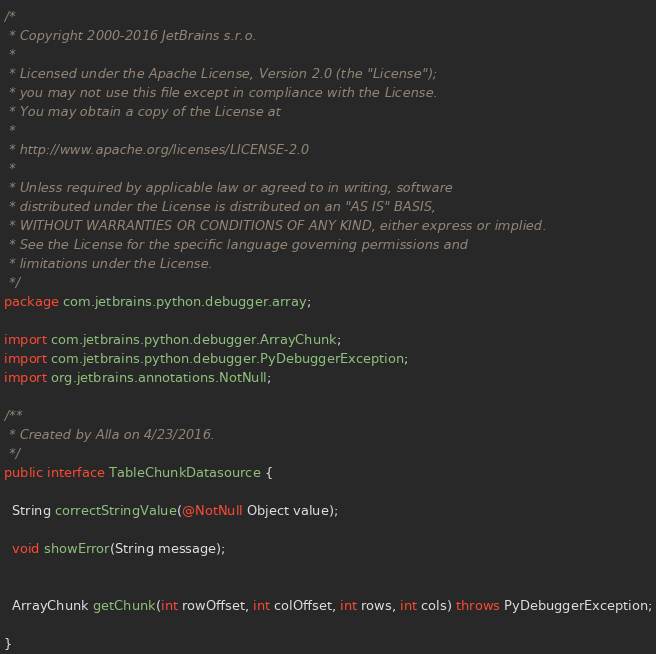Convert code to text. <code><loc_0><loc_0><loc_500><loc_500><_Java_>/*
 * Copyright 2000-2016 JetBrains s.r.o.
 *
 * Licensed under the Apache License, Version 2.0 (the "License");
 * you may not use this file except in compliance with the License.
 * You may obtain a copy of the License at
 *
 * http://www.apache.org/licenses/LICENSE-2.0
 *
 * Unless required by applicable law or agreed to in writing, software
 * distributed under the License is distributed on an "AS IS" BASIS,
 * WITHOUT WARRANTIES OR CONDITIONS OF ANY KIND, either express or implied.
 * See the License for the specific language governing permissions and
 * limitations under the License.
 */
package com.jetbrains.python.debugger.array;

import com.jetbrains.python.debugger.ArrayChunk;
import com.jetbrains.python.debugger.PyDebuggerException;
import org.jetbrains.annotations.NotNull;

/**
 * Created by Alla on 4/23/2016.
 */
public interface TableChunkDatasource {

  String correctStringValue(@NotNull Object value);

  void showError(String message);


  ArrayChunk getChunk(int rowOffset, int colOffset, int rows, int cols) throws PyDebuggerException;

}
</code> 